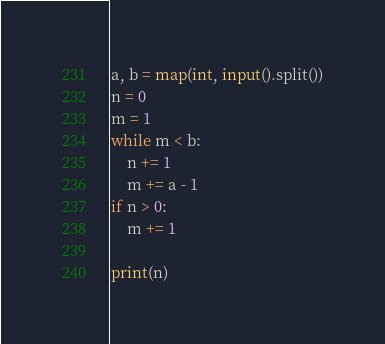<code> <loc_0><loc_0><loc_500><loc_500><_Python_>a, b = map(int, input().split())
n = 0
m = 1
while m < b:
    n += 1
    m += a - 1
if n > 0:
    m += 1

print(n)
</code> 